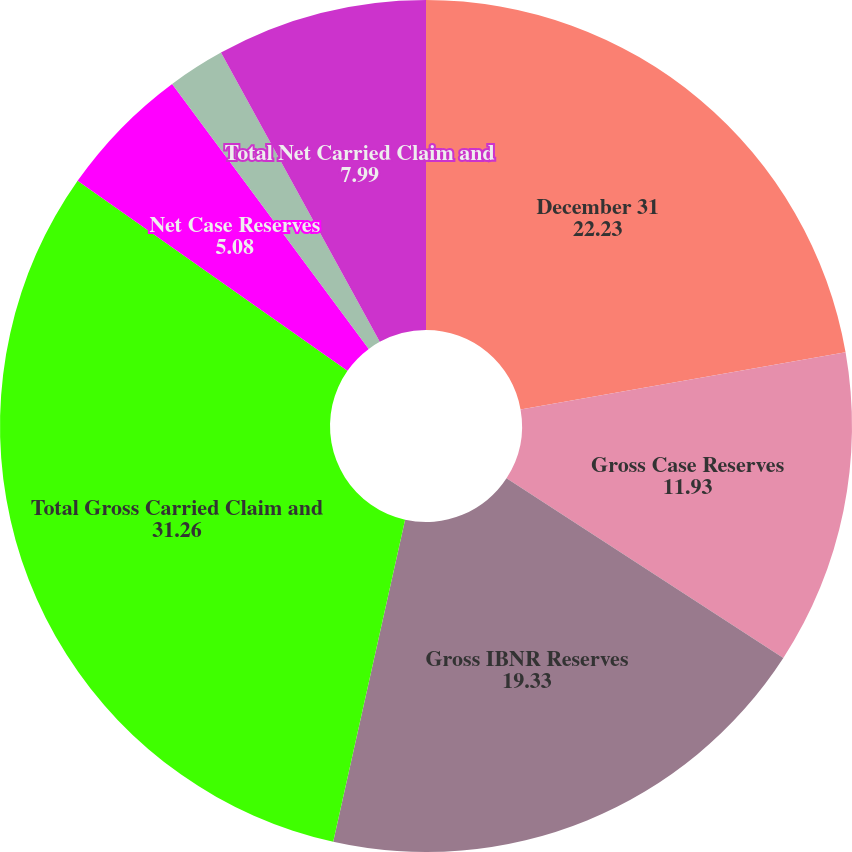Convert chart. <chart><loc_0><loc_0><loc_500><loc_500><pie_chart><fcel>December 31<fcel>Gross Case Reserves<fcel>Gross IBNR Reserves<fcel>Total Gross Carried Claim and<fcel>Net Case Reserves<fcel>Net IBNR Reserves<fcel>Total Net Carried Claim and<nl><fcel>22.23%<fcel>11.93%<fcel>19.33%<fcel>31.26%<fcel>5.08%<fcel>2.17%<fcel>7.99%<nl></chart> 